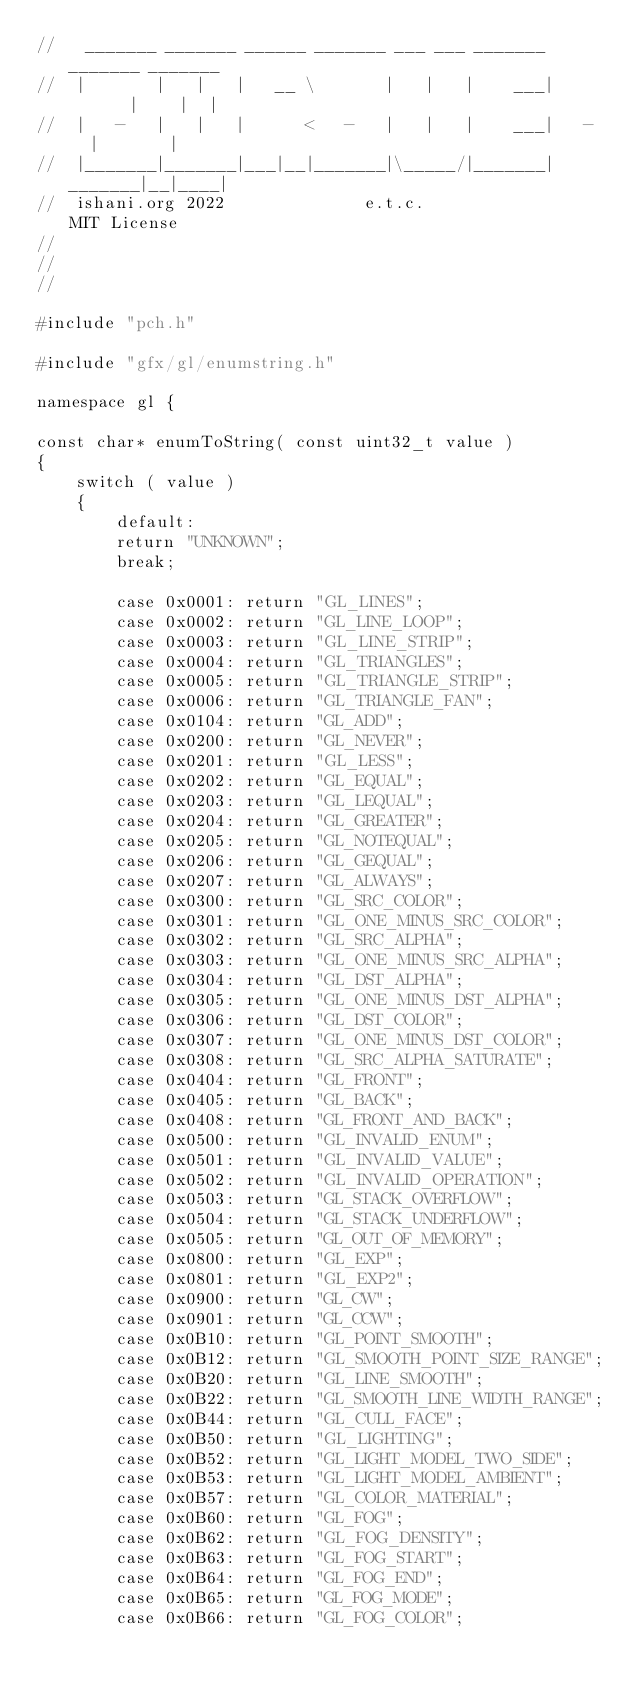<code> <loc_0><loc_0><loc_500><loc_500><_C++_>//   _______ _______ ______ _______ ___ ___ _______ _______ _______
//  |       |   |   |   __ \       |   |   |    ___|       |    |  |
//  |   -   |   |   |      <   -   |   |   |    ___|   -   |       |
//  |_______|_______|___|__|_______|\_____/|_______|_______|__|____|
//  ishani.org 2022              e.t.c.                  MIT License
//
//
//

#include "pch.h"

#include "gfx/gl/enumstring.h"

namespace gl {

const char* enumToString( const uint32_t value )
{
    switch ( value )
    {
        default:
        return "UNKNOWN";
        break;

        case 0x0001: return "GL_LINES";
        case 0x0002: return "GL_LINE_LOOP";
        case 0x0003: return "GL_LINE_STRIP";
        case 0x0004: return "GL_TRIANGLES";
        case 0x0005: return "GL_TRIANGLE_STRIP";
        case 0x0006: return "GL_TRIANGLE_FAN";
        case 0x0104: return "GL_ADD";
        case 0x0200: return "GL_NEVER";
        case 0x0201: return "GL_LESS";
        case 0x0202: return "GL_EQUAL";
        case 0x0203: return "GL_LEQUAL";
        case 0x0204: return "GL_GREATER";
        case 0x0205: return "GL_NOTEQUAL";
        case 0x0206: return "GL_GEQUAL";
        case 0x0207: return "GL_ALWAYS";
        case 0x0300: return "GL_SRC_COLOR";
        case 0x0301: return "GL_ONE_MINUS_SRC_COLOR";
        case 0x0302: return "GL_SRC_ALPHA";
        case 0x0303: return "GL_ONE_MINUS_SRC_ALPHA";
        case 0x0304: return "GL_DST_ALPHA";
        case 0x0305: return "GL_ONE_MINUS_DST_ALPHA";
        case 0x0306: return "GL_DST_COLOR";
        case 0x0307: return "GL_ONE_MINUS_DST_COLOR";
        case 0x0308: return "GL_SRC_ALPHA_SATURATE";
        case 0x0404: return "GL_FRONT";
        case 0x0405: return "GL_BACK";
        case 0x0408: return "GL_FRONT_AND_BACK";
        case 0x0500: return "GL_INVALID_ENUM";
        case 0x0501: return "GL_INVALID_VALUE";
        case 0x0502: return "GL_INVALID_OPERATION";
        case 0x0503: return "GL_STACK_OVERFLOW";
        case 0x0504: return "GL_STACK_UNDERFLOW";
        case 0x0505: return "GL_OUT_OF_MEMORY";
        case 0x0800: return "GL_EXP";
        case 0x0801: return "GL_EXP2";
        case 0x0900: return "GL_CW";
        case 0x0901: return "GL_CCW";
        case 0x0B10: return "GL_POINT_SMOOTH";
        case 0x0B12: return "GL_SMOOTH_POINT_SIZE_RANGE";
        case 0x0B20: return "GL_LINE_SMOOTH";
        case 0x0B22: return "GL_SMOOTH_LINE_WIDTH_RANGE";
        case 0x0B44: return "GL_CULL_FACE";
        case 0x0B50: return "GL_LIGHTING";
        case 0x0B52: return "GL_LIGHT_MODEL_TWO_SIDE";
        case 0x0B53: return "GL_LIGHT_MODEL_AMBIENT";
        case 0x0B57: return "GL_COLOR_MATERIAL";
        case 0x0B60: return "GL_FOG";
        case 0x0B62: return "GL_FOG_DENSITY";
        case 0x0B63: return "GL_FOG_START";
        case 0x0B64: return "GL_FOG_END";
        case 0x0B65: return "GL_FOG_MODE";
        case 0x0B66: return "GL_FOG_COLOR";</code> 